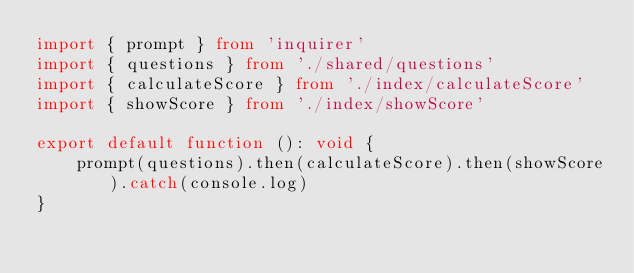Convert code to text. <code><loc_0><loc_0><loc_500><loc_500><_TypeScript_>import { prompt } from 'inquirer'
import { questions } from './shared/questions'
import { calculateScore } from './index/calculateScore'
import { showScore } from './index/showScore'

export default function (): void {
    prompt(questions).then(calculateScore).then(showScore).catch(console.log)
}
</code> 